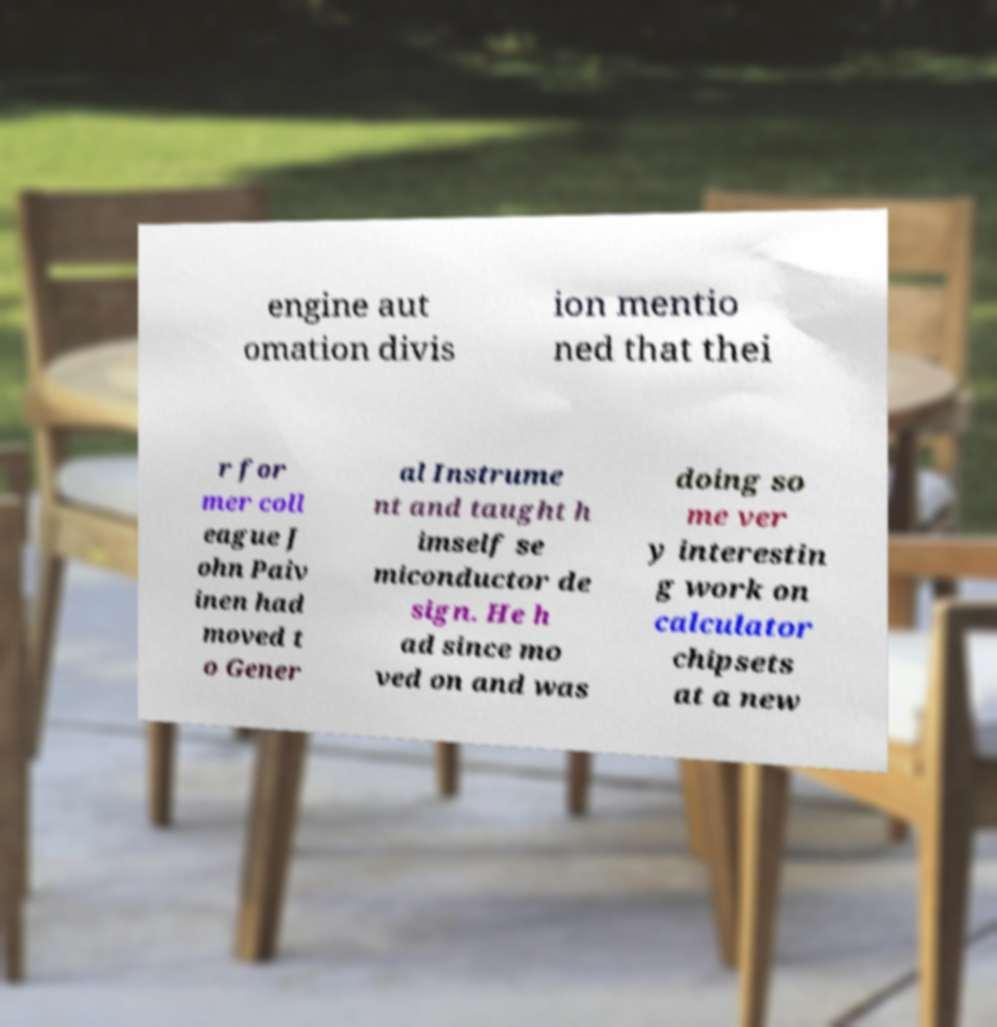I need the written content from this picture converted into text. Can you do that? engine aut omation divis ion mentio ned that thei r for mer coll eague J ohn Paiv inen had moved t o Gener al Instrume nt and taught h imself se miconductor de sign. He h ad since mo ved on and was doing so me ver y interestin g work on calculator chipsets at a new 